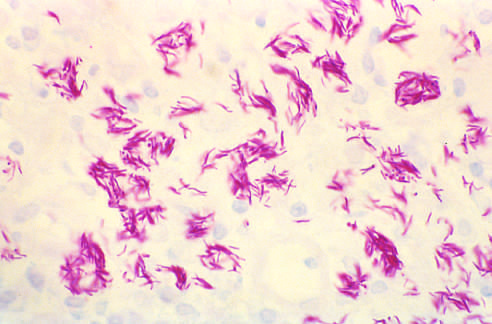does mycobacterium avium infection in a duodenal biopsy from a patient with aids show massive intracellular macrophage infection with acid-fast organisms filamentous and pink in this acid-fast stain preparation?
Answer the question using a single word or phrase. Yes 